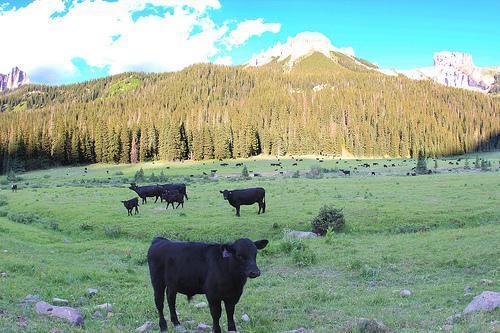How many cows?
Give a very brief answer. 6. 